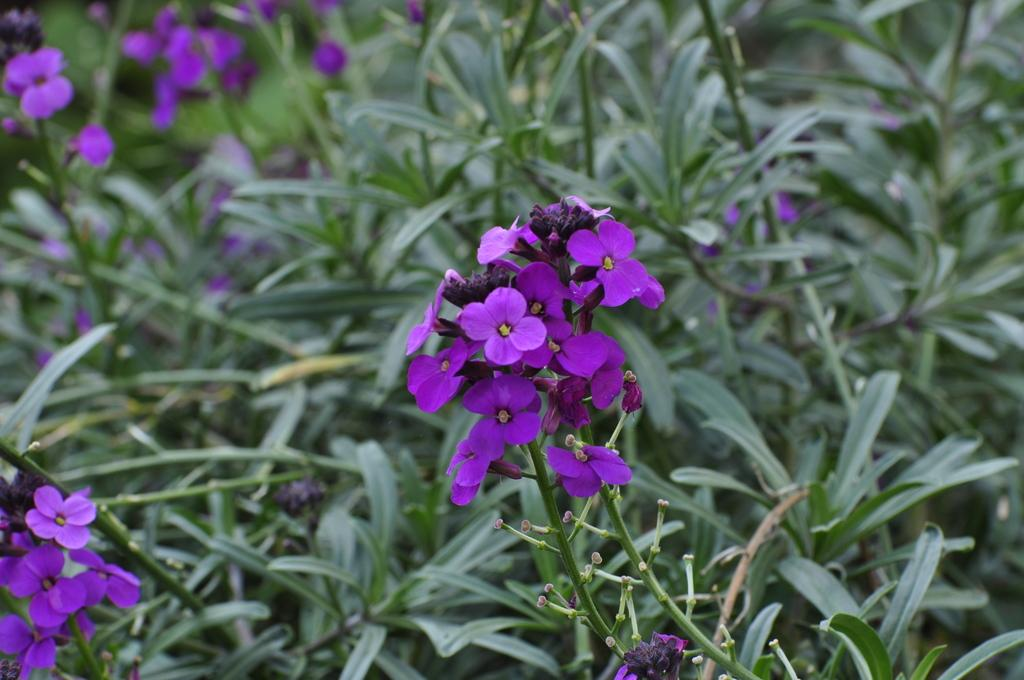What types of vegetation can be seen in the image? There are many plants in the image. Are there any specific features of the plants that can be observed? Yes, there are flowers present in the image. What type of square object is being used to draw the attention of the flowers in the image? There is no square object or any indication of drawing attention in the image; it simply features plants and flowers. 